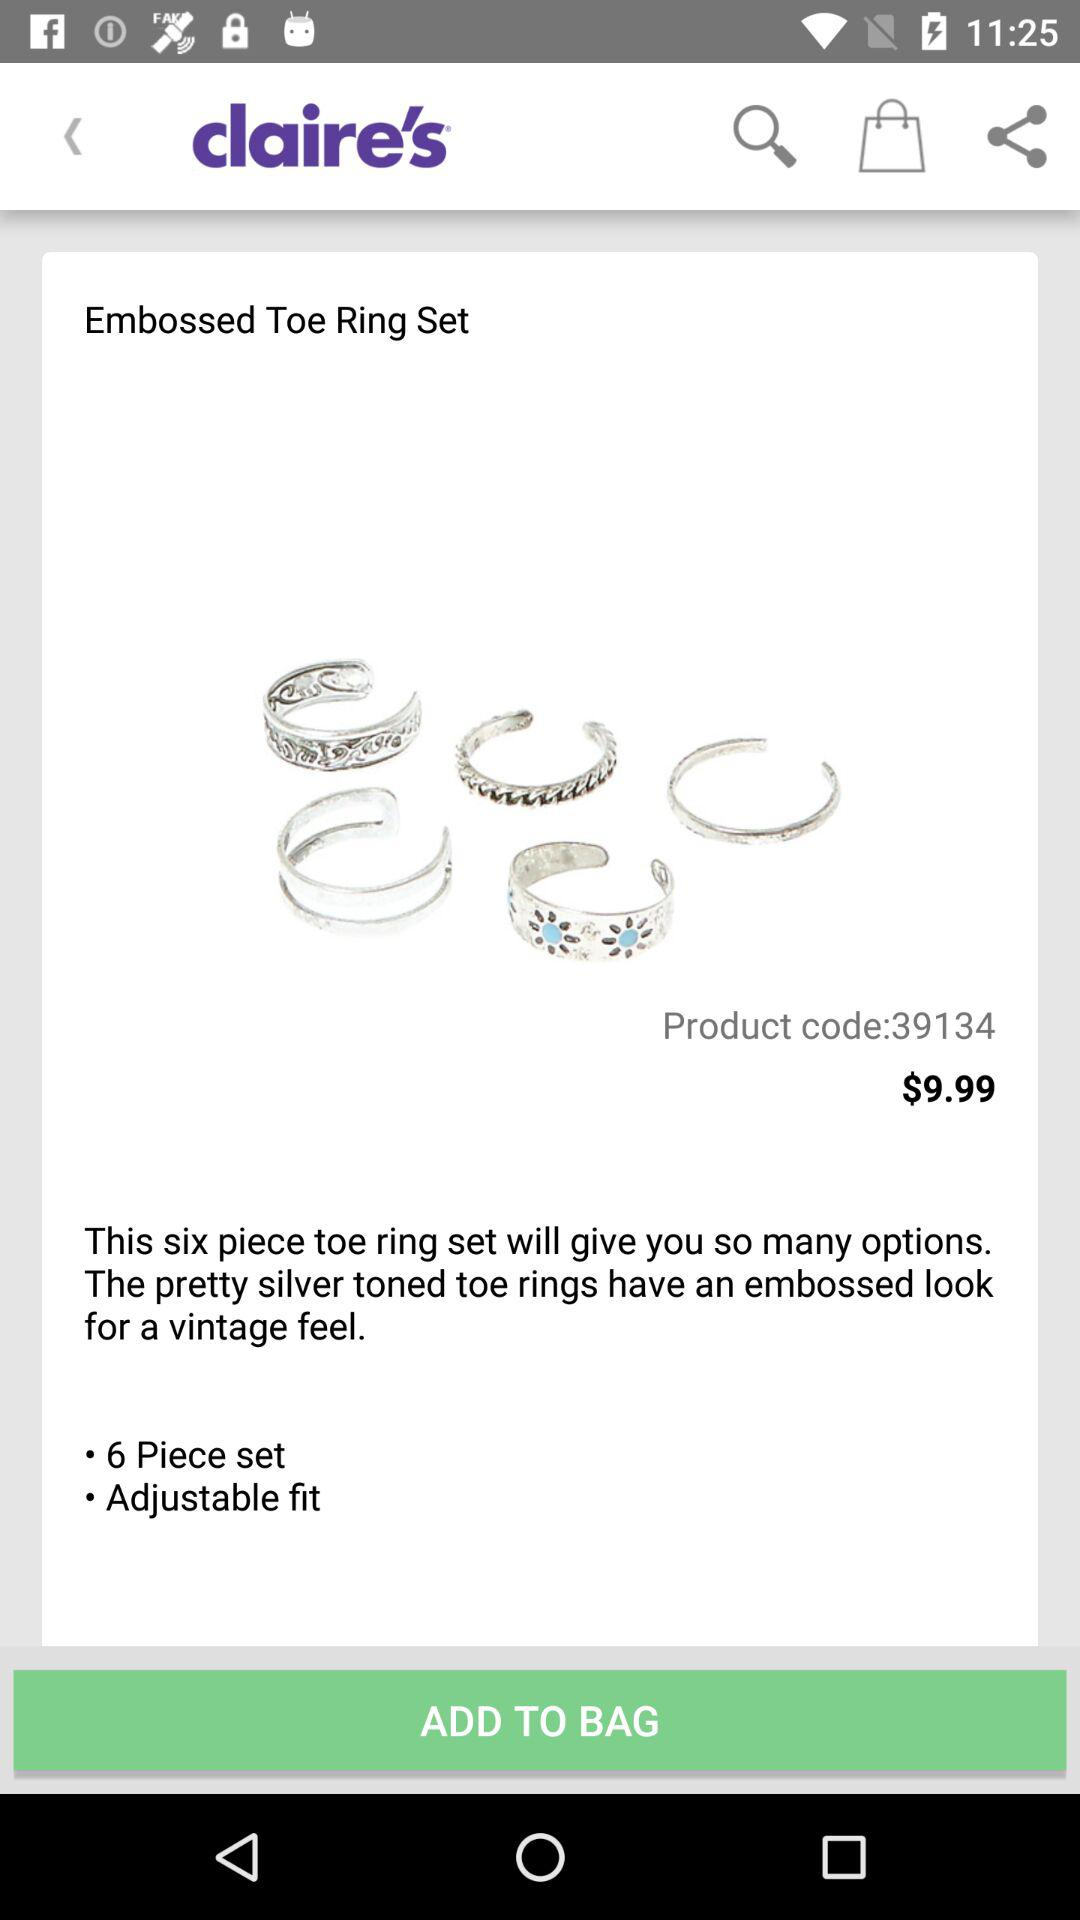What is the price of the embossed toe ring set? The price is $9.99. 